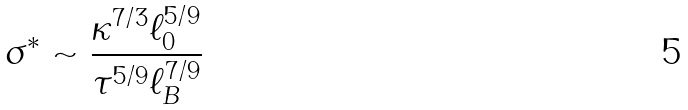Convert formula to latex. <formula><loc_0><loc_0><loc_500><loc_500>\sigma ^ { * } \sim \frac { \kappa ^ { 7 / 3 } \ell _ { 0 } ^ { 5 / 9 } } { \tau ^ { 5 / 9 } \ell _ { B } ^ { 7 / 9 } }</formula> 